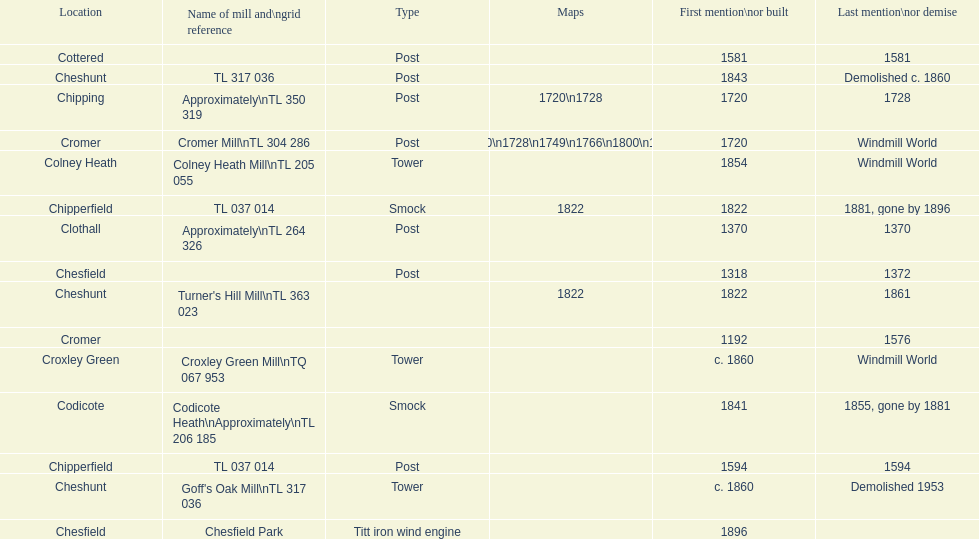What is the number of mills first mentioned or built in the 1800s? 8. 